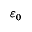<formula> <loc_0><loc_0><loc_500><loc_500>\varepsilon _ { 0 }</formula> 